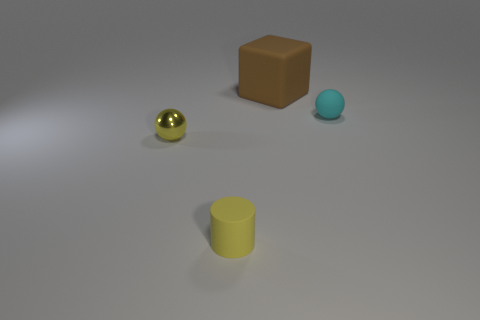Is there anything else that has the same material as the yellow ball?
Keep it short and to the point. No. Are there more small metal balls behind the small cyan ball than brown rubber things?
Provide a short and direct response. No. Do the ball that is right of the brown matte cube and the tiny yellow ball have the same material?
Your answer should be very brief. No. There is a sphere that is left of the tiny rubber thing to the left of the small ball to the right of the big brown rubber cube; what size is it?
Your answer should be very brief. Small. What size is the yellow cylinder that is the same material as the tiny cyan ball?
Offer a very short reply. Small. There is a matte thing that is both behind the tiny yellow rubber cylinder and in front of the brown thing; what is its color?
Give a very brief answer. Cyan. There is a small matte thing on the right side of the small yellow rubber cylinder; does it have the same shape as the matte object that is to the left of the large rubber cube?
Your answer should be very brief. No. What is the material of the tiny yellow object that is left of the tiny yellow rubber cylinder?
Offer a terse response. Metal. What size is the ball that is the same color as the tiny matte cylinder?
Your answer should be compact. Small. How many objects are either brown cubes that are right of the tiny yellow shiny sphere or brown metal balls?
Keep it short and to the point. 1. 